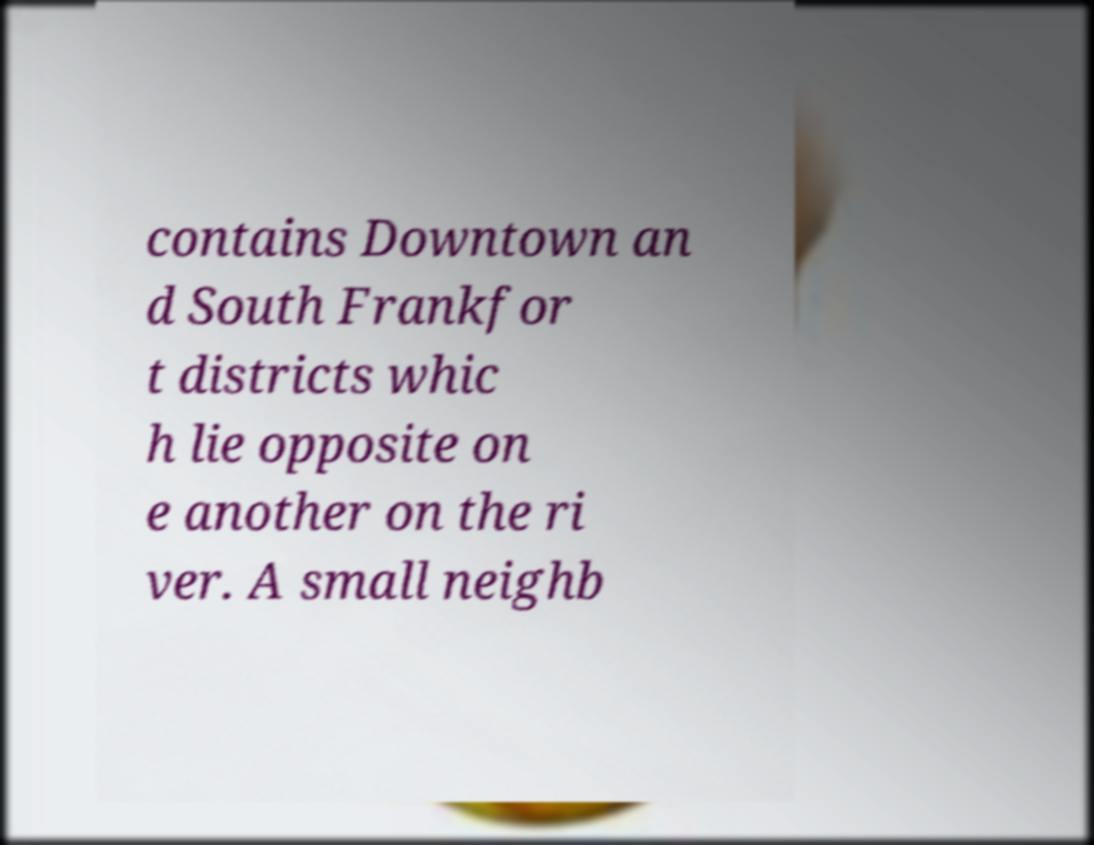I need the written content from this picture converted into text. Can you do that? contains Downtown an d South Frankfor t districts whic h lie opposite on e another on the ri ver. A small neighb 